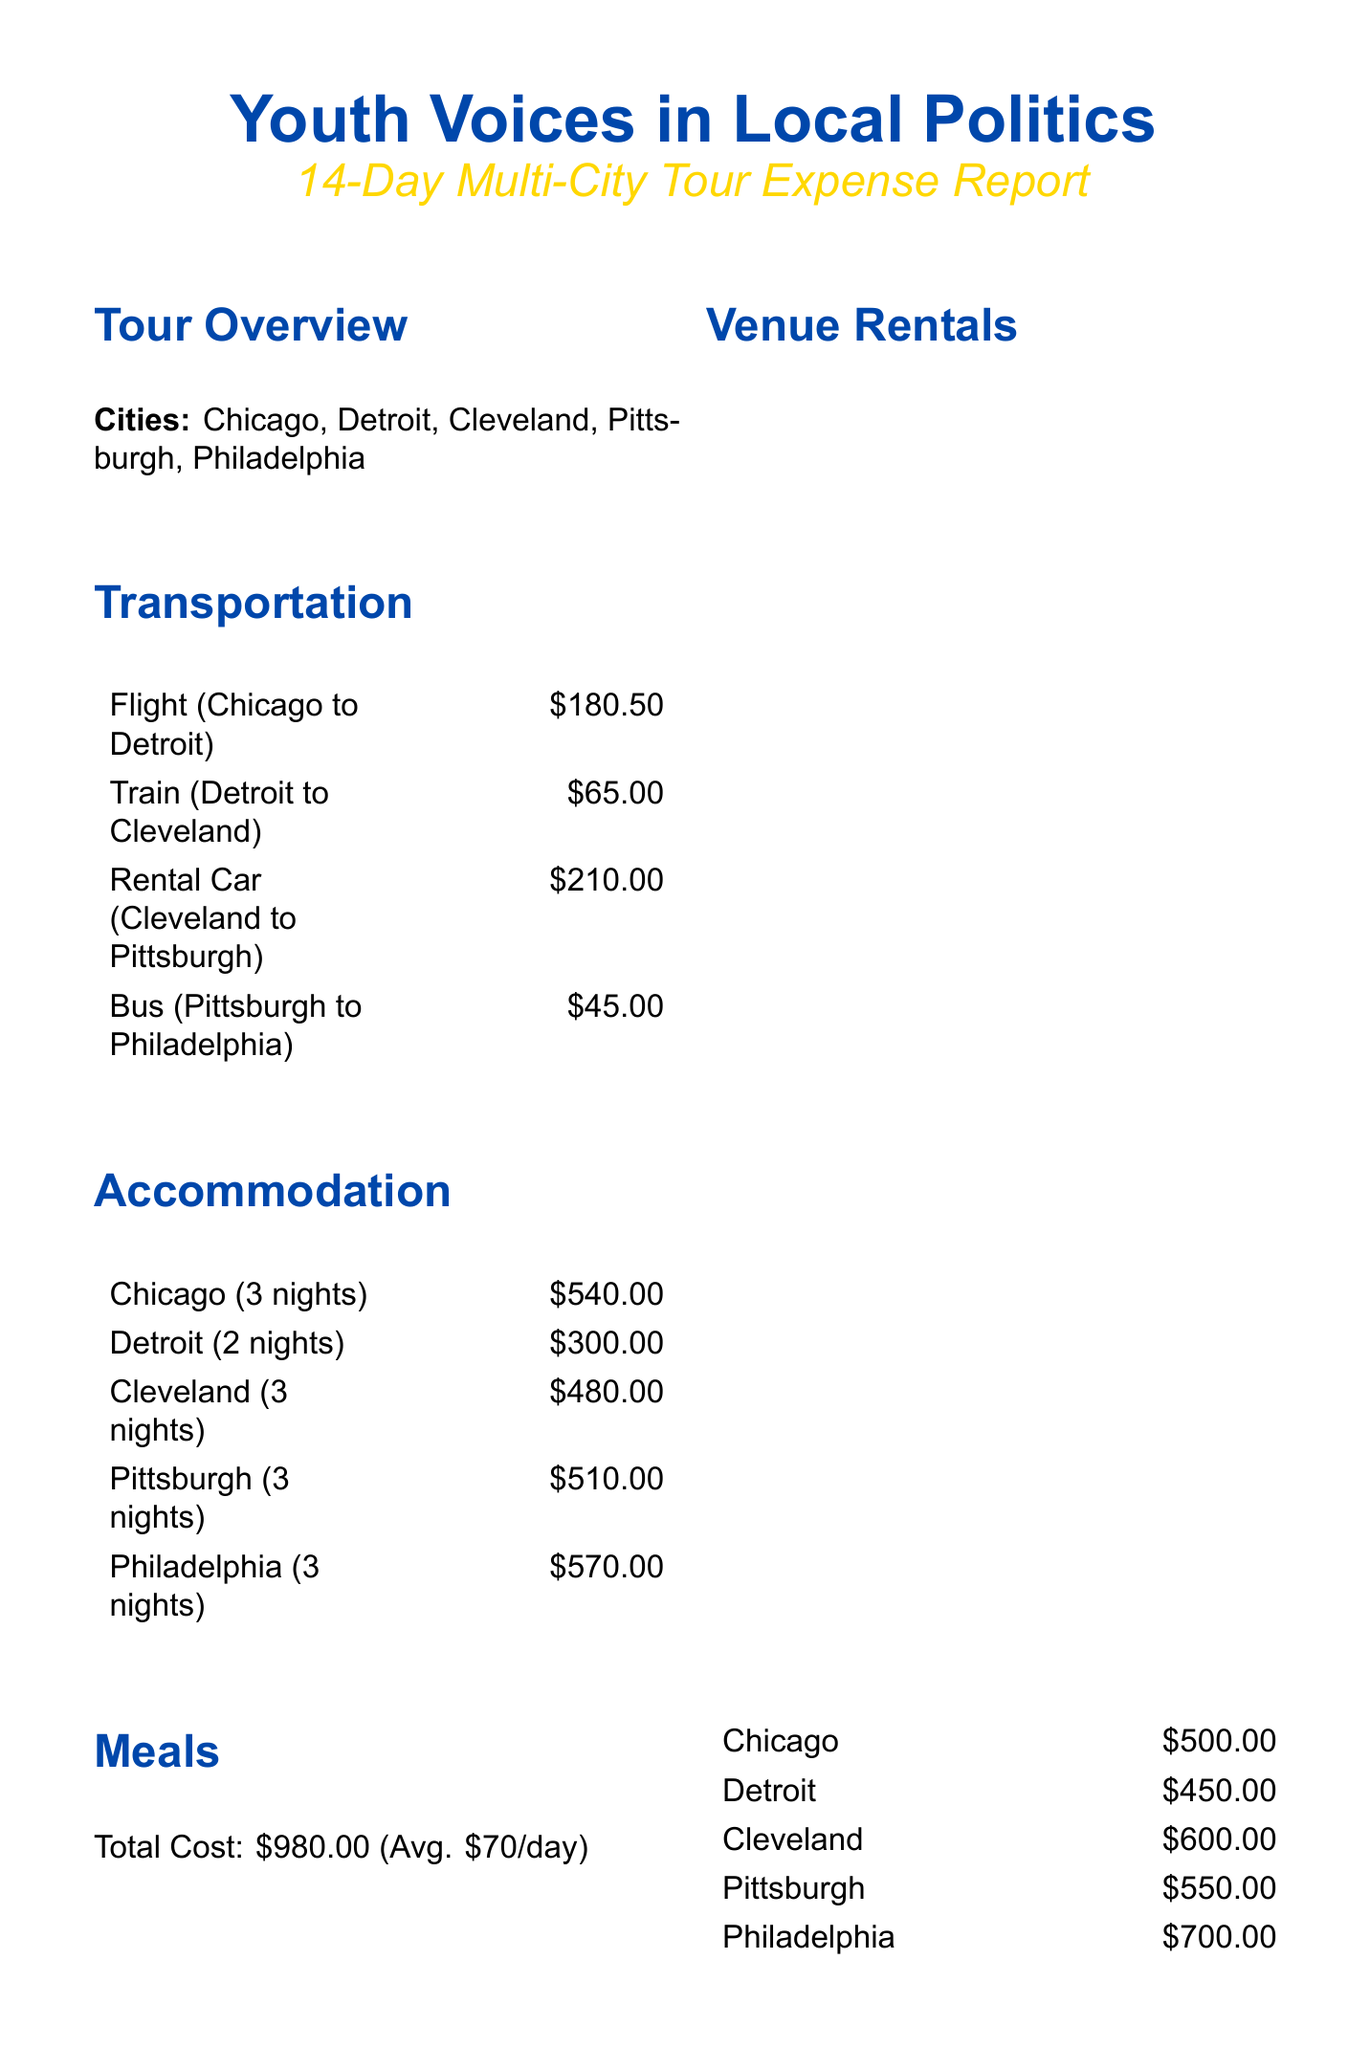what is the total cost of meals? The total cost for meals is stated directly in the expenses section of the document.
Answer: $980.00 how many cities were visited during the tour? The cities are listed in the overview section, providing a count of the cities involved in the tour.
Answer: 5 what was the accommodation cost per night in Philadelphia? The accommodation section includes the cost per night for each city, specifically mentioning Philadelphia's hotel cost.
Answer: $190.00 who was the guest speaker with the highest honorarium? The guest speakers and their honorariums are listed, indicating which one received the highest payment.
Answer: Alexandria Ocasio-Cortez what is the total amount provided by the National Endowment for Democracy? The amount is listed under the funding sources section, reflecting the total funding from this particular source.
Answer: $15,000.00 how many nights was the hotel booked in Cleveland? The accommodation section specifies the number of nights stayed in Cleveland, as indicated in the hotel entry.
Answer: 3 what is the average meal cost per day? The average meal cost is directly mentioned in the meals section of the expenses.
Answer: $70.00 what was the total cost for venue rentals in Pittsburgh? The venue rentals section lists the costs for local venues, specifically detailing the charge for Pittsburgh.
Answer: $550.00 what is one expected outcome of the tour? The expected outcomes are outlined in a bullet-point format, highlighting goals for engagement and participation in politics.
Answer: Increase youth voter registration by 15% in targeted cities 